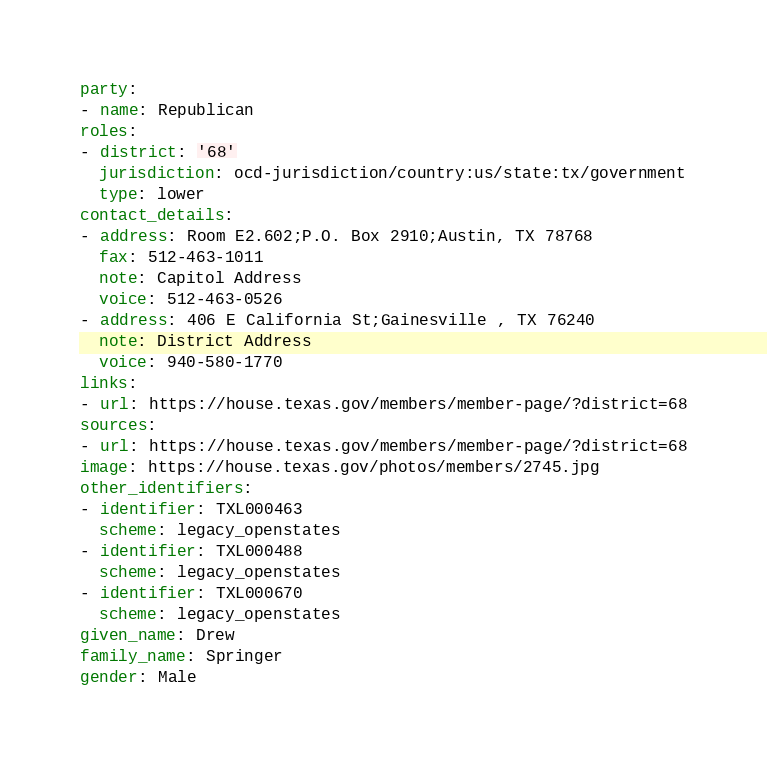Convert code to text. <code><loc_0><loc_0><loc_500><loc_500><_YAML_>party:
- name: Republican
roles:
- district: '68'
  jurisdiction: ocd-jurisdiction/country:us/state:tx/government
  type: lower
contact_details:
- address: Room E2.602;P.O. Box 2910;Austin, TX 78768
  fax: 512-463-1011
  note: Capitol Address
  voice: 512-463-0526
- address: 406 E California St;Gainesville , TX 76240
  note: District Address
  voice: 940-580-1770
links:
- url: https://house.texas.gov/members/member-page/?district=68
sources:
- url: https://house.texas.gov/members/member-page/?district=68
image: https://house.texas.gov/photos/members/2745.jpg
other_identifiers:
- identifier: TXL000463
  scheme: legacy_openstates
- identifier: TXL000488
  scheme: legacy_openstates
- identifier: TXL000670
  scheme: legacy_openstates
given_name: Drew
family_name: Springer
gender: Male
</code> 